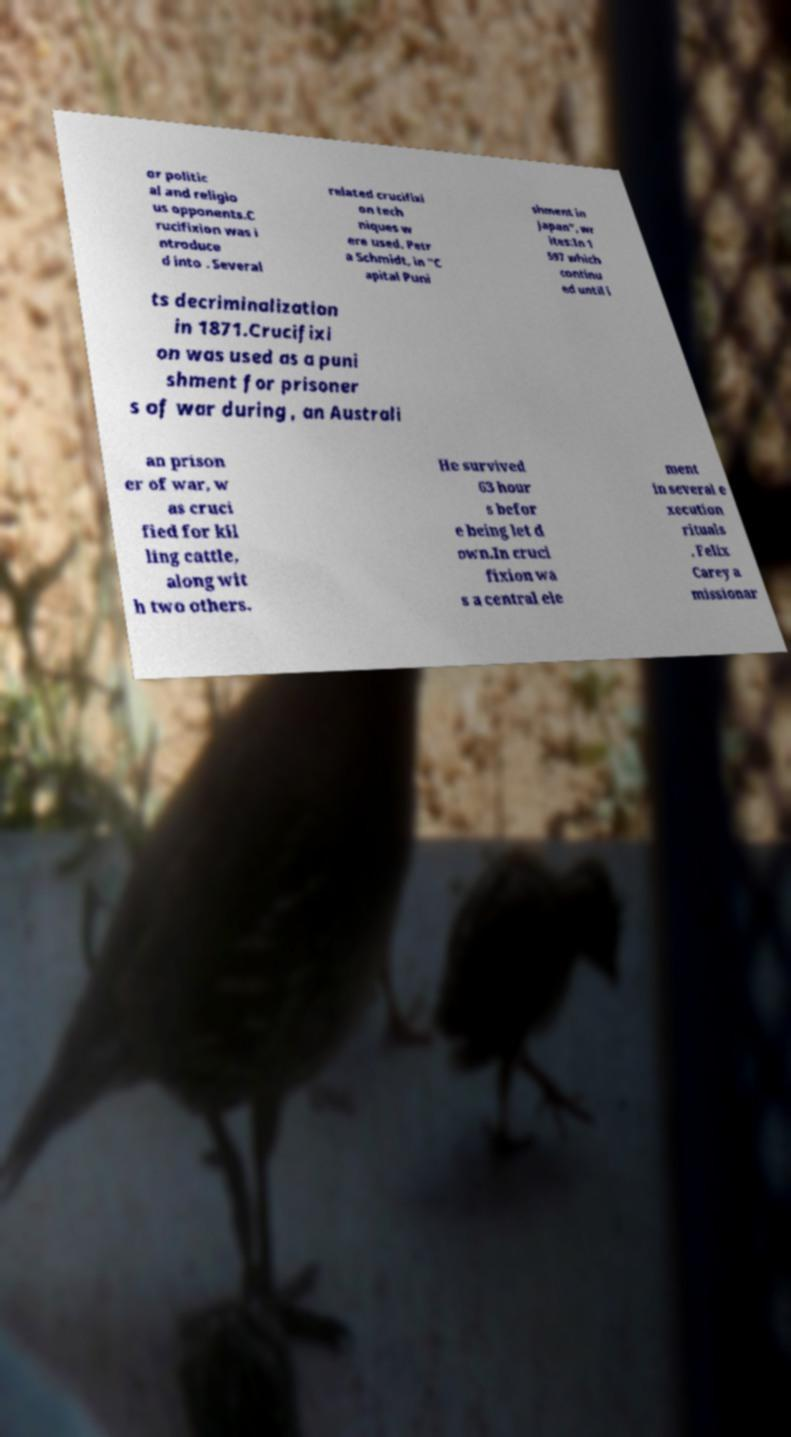What messages or text are displayed in this image? I need them in a readable, typed format. or politic al and religio us opponents.C rucifixion was i ntroduce d into . Several related crucifixi on tech niques w ere used. Petr a Schmidt, in "C apital Puni shment in Japan", wr ites:In 1 597 which continu ed until i ts decriminalization in 1871.Crucifixi on was used as a puni shment for prisoner s of war during , an Australi an prison er of war, w as cruci fied for kil ling cattle, along wit h two others. He survived 63 hour s befor e being let d own.In cruci fixion wa s a central ele ment in several e xecution rituals . Felix Carey a missionar 